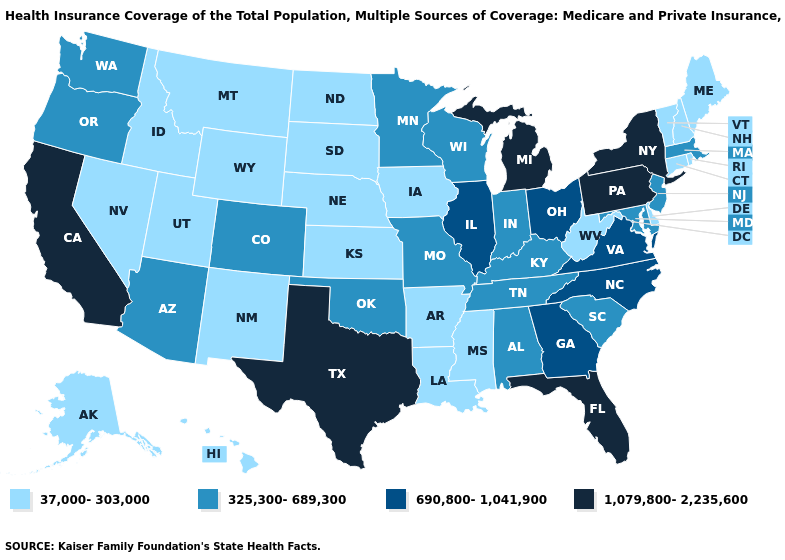Name the states that have a value in the range 325,300-689,300?
Answer briefly. Alabama, Arizona, Colorado, Indiana, Kentucky, Maryland, Massachusetts, Minnesota, Missouri, New Jersey, Oklahoma, Oregon, South Carolina, Tennessee, Washington, Wisconsin. Is the legend a continuous bar?
Quick response, please. No. What is the value of South Dakota?
Be succinct. 37,000-303,000. Among the states that border Virginia , which have the highest value?
Be succinct. North Carolina. Does Pennsylvania have the highest value in the USA?
Concise answer only. Yes. Name the states that have a value in the range 37,000-303,000?
Concise answer only. Alaska, Arkansas, Connecticut, Delaware, Hawaii, Idaho, Iowa, Kansas, Louisiana, Maine, Mississippi, Montana, Nebraska, Nevada, New Hampshire, New Mexico, North Dakota, Rhode Island, South Dakota, Utah, Vermont, West Virginia, Wyoming. What is the value of Delaware?
Quick response, please. 37,000-303,000. Name the states that have a value in the range 690,800-1,041,900?
Write a very short answer. Georgia, Illinois, North Carolina, Ohio, Virginia. What is the lowest value in states that border Connecticut?
Write a very short answer. 37,000-303,000. What is the lowest value in states that border Alabama?
Quick response, please. 37,000-303,000. Name the states that have a value in the range 1,079,800-2,235,600?
Quick response, please. California, Florida, Michigan, New York, Pennsylvania, Texas. Does Vermont have the lowest value in the USA?
Give a very brief answer. Yes. Among the states that border New Hampshire , does Vermont have the lowest value?
Be succinct. Yes. Name the states that have a value in the range 325,300-689,300?
Be succinct. Alabama, Arizona, Colorado, Indiana, Kentucky, Maryland, Massachusetts, Minnesota, Missouri, New Jersey, Oklahoma, Oregon, South Carolina, Tennessee, Washington, Wisconsin. What is the lowest value in the USA?
Write a very short answer. 37,000-303,000. 